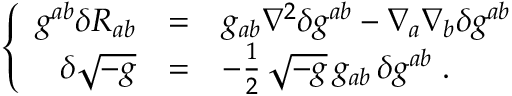Convert formula to latex. <formula><loc_0><loc_0><loc_500><loc_500>\left \{ \begin{array} { r c l } { { g ^ { a b } \delta R _ { a b } } } & { = } & { { g _ { a b } \nabla ^ { 2 } \delta g ^ { a b } - \nabla _ { a } \nabla _ { b } \delta g ^ { a b } } } \\ { { \delta \sqrt { - g } } } & { = } & { { - { \frac { 1 } { 2 } } \, \sqrt { - g } \, g _ { a b } \, \delta g ^ { a b } \, . } } \end{array}</formula> 